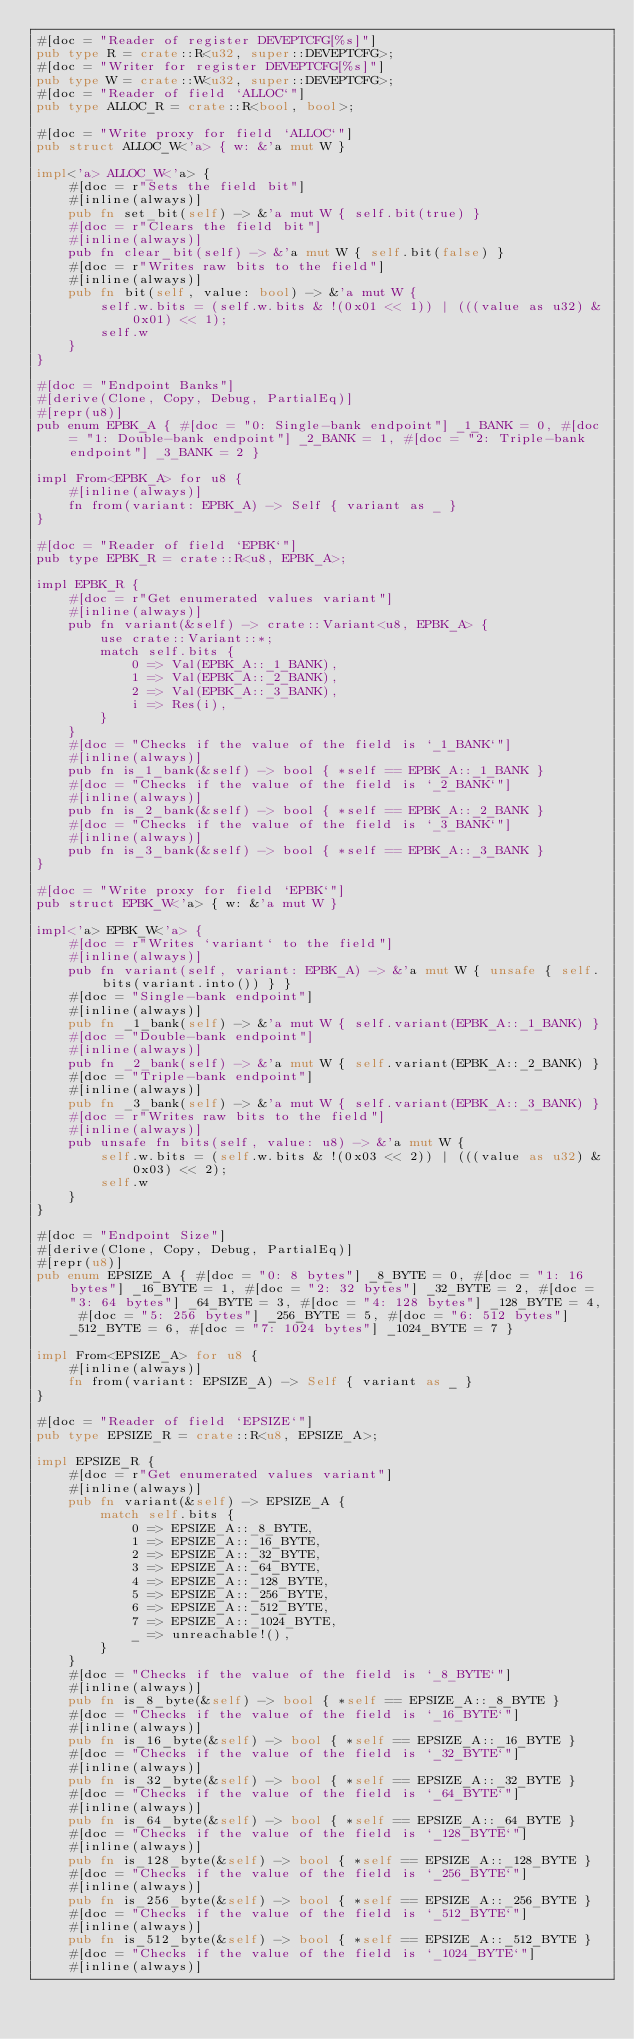Convert code to text. <code><loc_0><loc_0><loc_500><loc_500><_Rust_>#[doc = "Reader of register DEVEPTCFG[%s]"]
pub type R = crate::R<u32, super::DEVEPTCFG>;
#[doc = "Writer for register DEVEPTCFG[%s]"]
pub type W = crate::W<u32, super::DEVEPTCFG>;
#[doc = "Reader of field `ALLOC`"]
pub type ALLOC_R = crate::R<bool, bool>;

#[doc = "Write proxy for field `ALLOC`"]
pub struct ALLOC_W<'a> { w: &'a mut W }

impl<'a> ALLOC_W<'a> {
    #[doc = r"Sets the field bit"]
    #[inline(always)]
    pub fn set_bit(self) -> &'a mut W { self.bit(true) }
    #[doc = r"Clears the field bit"]
    #[inline(always)]
    pub fn clear_bit(self) -> &'a mut W { self.bit(false) }
    #[doc = r"Writes raw bits to the field"]
    #[inline(always)]
    pub fn bit(self, value: bool) -> &'a mut W {
        self.w.bits = (self.w.bits & !(0x01 << 1)) | (((value as u32) & 0x01) << 1);
        self.w
    }
}

#[doc = "Endpoint Banks"]
#[derive(Clone, Copy, Debug, PartialEq)]
#[repr(u8)]
pub enum EPBK_A { #[doc = "0: Single-bank endpoint"] _1_BANK = 0, #[doc = "1: Double-bank endpoint"] _2_BANK = 1, #[doc = "2: Triple-bank endpoint"] _3_BANK = 2 }

impl From<EPBK_A> for u8 {
    #[inline(always)]
    fn from(variant: EPBK_A) -> Self { variant as _ }
}

#[doc = "Reader of field `EPBK`"]
pub type EPBK_R = crate::R<u8, EPBK_A>;

impl EPBK_R {
    #[doc = r"Get enumerated values variant"]
    #[inline(always)]
    pub fn variant(&self) -> crate::Variant<u8, EPBK_A> {
        use crate::Variant::*;
        match self.bits {
            0 => Val(EPBK_A::_1_BANK),
            1 => Val(EPBK_A::_2_BANK),
            2 => Val(EPBK_A::_3_BANK),
            i => Res(i),
        }
    }
    #[doc = "Checks if the value of the field is `_1_BANK`"]
    #[inline(always)]
    pub fn is_1_bank(&self) -> bool { *self == EPBK_A::_1_BANK }
    #[doc = "Checks if the value of the field is `_2_BANK`"]
    #[inline(always)]
    pub fn is_2_bank(&self) -> bool { *self == EPBK_A::_2_BANK }
    #[doc = "Checks if the value of the field is `_3_BANK`"]
    #[inline(always)]
    pub fn is_3_bank(&self) -> bool { *self == EPBK_A::_3_BANK }
}

#[doc = "Write proxy for field `EPBK`"]
pub struct EPBK_W<'a> { w: &'a mut W }

impl<'a> EPBK_W<'a> {
    #[doc = r"Writes `variant` to the field"]
    #[inline(always)]
    pub fn variant(self, variant: EPBK_A) -> &'a mut W { unsafe { self.bits(variant.into()) } }
    #[doc = "Single-bank endpoint"]
    #[inline(always)]
    pub fn _1_bank(self) -> &'a mut W { self.variant(EPBK_A::_1_BANK) }
    #[doc = "Double-bank endpoint"]
    #[inline(always)]
    pub fn _2_bank(self) -> &'a mut W { self.variant(EPBK_A::_2_BANK) }
    #[doc = "Triple-bank endpoint"]
    #[inline(always)]
    pub fn _3_bank(self) -> &'a mut W { self.variant(EPBK_A::_3_BANK) }
    #[doc = r"Writes raw bits to the field"]
    #[inline(always)]
    pub unsafe fn bits(self, value: u8) -> &'a mut W {
        self.w.bits = (self.w.bits & !(0x03 << 2)) | (((value as u32) & 0x03) << 2);
        self.w
    }
}

#[doc = "Endpoint Size"]
#[derive(Clone, Copy, Debug, PartialEq)]
#[repr(u8)]
pub enum EPSIZE_A { #[doc = "0: 8 bytes"] _8_BYTE = 0, #[doc = "1: 16 bytes"] _16_BYTE = 1, #[doc = "2: 32 bytes"] _32_BYTE = 2, #[doc = "3: 64 bytes"] _64_BYTE = 3, #[doc = "4: 128 bytes"] _128_BYTE = 4, #[doc = "5: 256 bytes"] _256_BYTE = 5, #[doc = "6: 512 bytes"] _512_BYTE = 6, #[doc = "7: 1024 bytes"] _1024_BYTE = 7 }

impl From<EPSIZE_A> for u8 {
    #[inline(always)]
    fn from(variant: EPSIZE_A) -> Self { variant as _ }
}

#[doc = "Reader of field `EPSIZE`"]
pub type EPSIZE_R = crate::R<u8, EPSIZE_A>;

impl EPSIZE_R {
    #[doc = r"Get enumerated values variant"]
    #[inline(always)]
    pub fn variant(&self) -> EPSIZE_A {
        match self.bits {
            0 => EPSIZE_A::_8_BYTE,
            1 => EPSIZE_A::_16_BYTE,
            2 => EPSIZE_A::_32_BYTE,
            3 => EPSIZE_A::_64_BYTE,
            4 => EPSIZE_A::_128_BYTE,
            5 => EPSIZE_A::_256_BYTE,
            6 => EPSIZE_A::_512_BYTE,
            7 => EPSIZE_A::_1024_BYTE,
            _ => unreachable!(),
        }
    }
    #[doc = "Checks if the value of the field is `_8_BYTE`"]
    #[inline(always)]
    pub fn is_8_byte(&self) -> bool { *self == EPSIZE_A::_8_BYTE }
    #[doc = "Checks if the value of the field is `_16_BYTE`"]
    #[inline(always)]
    pub fn is_16_byte(&self) -> bool { *self == EPSIZE_A::_16_BYTE }
    #[doc = "Checks if the value of the field is `_32_BYTE`"]
    #[inline(always)]
    pub fn is_32_byte(&self) -> bool { *self == EPSIZE_A::_32_BYTE }
    #[doc = "Checks if the value of the field is `_64_BYTE`"]
    #[inline(always)]
    pub fn is_64_byte(&self) -> bool { *self == EPSIZE_A::_64_BYTE }
    #[doc = "Checks if the value of the field is `_128_BYTE`"]
    #[inline(always)]
    pub fn is_128_byte(&self) -> bool { *self == EPSIZE_A::_128_BYTE }
    #[doc = "Checks if the value of the field is `_256_BYTE`"]
    #[inline(always)]
    pub fn is_256_byte(&self) -> bool { *self == EPSIZE_A::_256_BYTE }
    #[doc = "Checks if the value of the field is `_512_BYTE`"]
    #[inline(always)]
    pub fn is_512_byte(&self) -> bool { *self == EPSIZE_A::_512_BYTE }
    #[doc = "Checks if the value of the field is `_1024_BYTE`"]
    #[inline(always)]</code> 